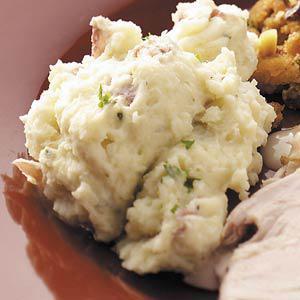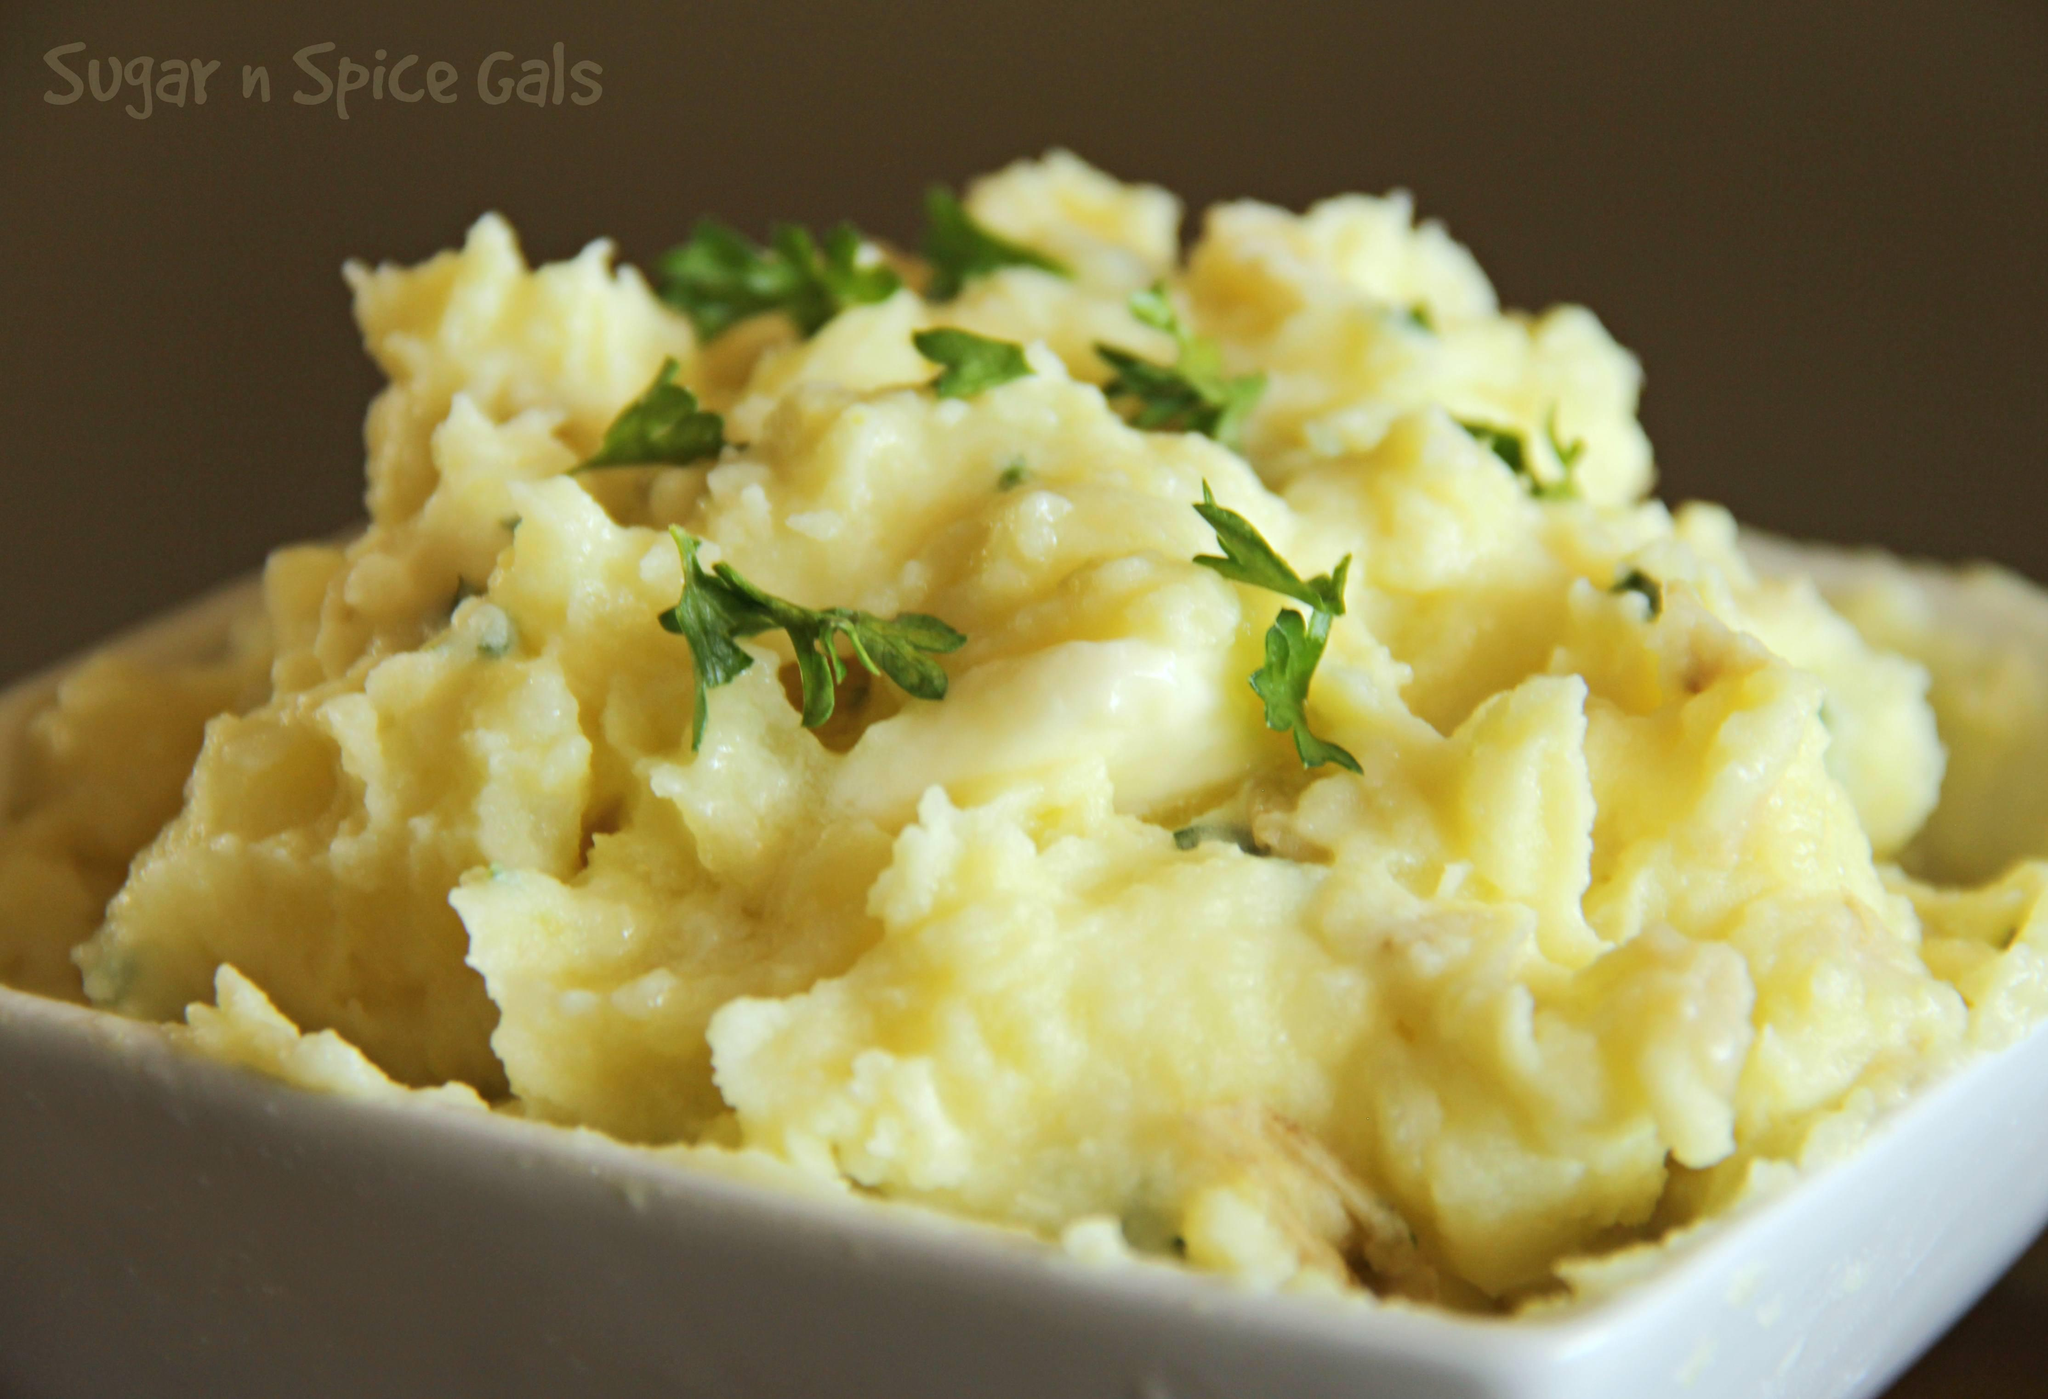The first image is the image on the left, the second image is the image on the right. Considering the images on both sides, is "Every serving of mashed potatoes has a green herb in it, and one serving appears more buttery or yellow than the other." valid? Answer yes or no. Yes. The first image is the image on the left, the second image is the image on the right. Examine the images to the left and right. Is the description "The left and right image contains the same of white serving dishes that hold mash potatoes." accurate? Answer yes or no. No. 